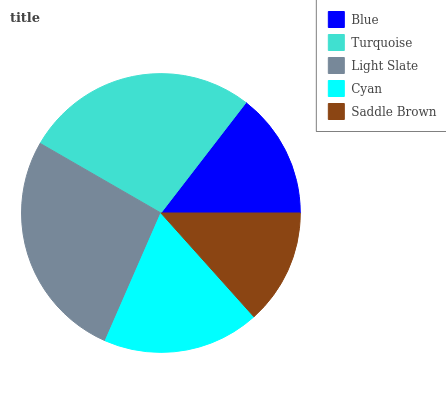Is Saddle Brown the minimum?
Answer yes or no. Yes. Is Turquoise the maximum?
Answer yes or no. Yes. Is Light Slate the minimum?
Answer yes or no. No. Is Light Slate the maximum?
Answer yes or no. No. Is Turquoise greater than Light Slate?
Answer yes or no. Yes. Is Light Slate less than Turquoise?
Answer yes or no. Yes. Is Light Slate greater than Turquoise?
Answer yes or no. No. Is Turquoise less than Light Slate?
Answer yes or no. No. Is Cyan the high median?
Answer yes or no. Yes. Is Cyan the low median?
Answer yes or no. Yes. Is Blue the high median?
Answer yes or no. No. Is Saddle Brown the low median?
Answer yes or no. No. 